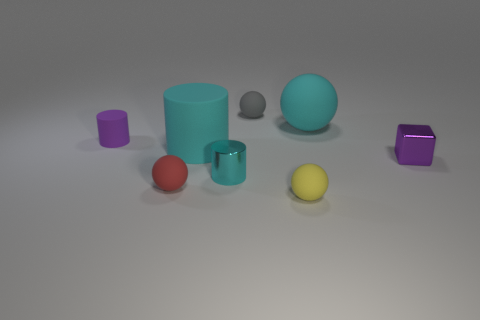Add 1 rubber balls. How many objects exist? 9 Subtract all yellow spheres. How many spheres are left? 3 Subtract 4 balls. How many balls are left? 0 Add 1 cylinders. How many cylinders are left? 4 Add 3 tiny purple shiny objects. How many tiny purple shiny objects exist? 4 Subtract all red balls. How many balls are left? 3 Subtract 1 yellow balls. How many objects are left? 7 Subtract all cylinders. How many objects are left? 5 Subtract all cyan blocks. Subtract all yellow cylinders. How many blocks are left? 1 Subtract all green balls. How many red cylinders are left? 0 